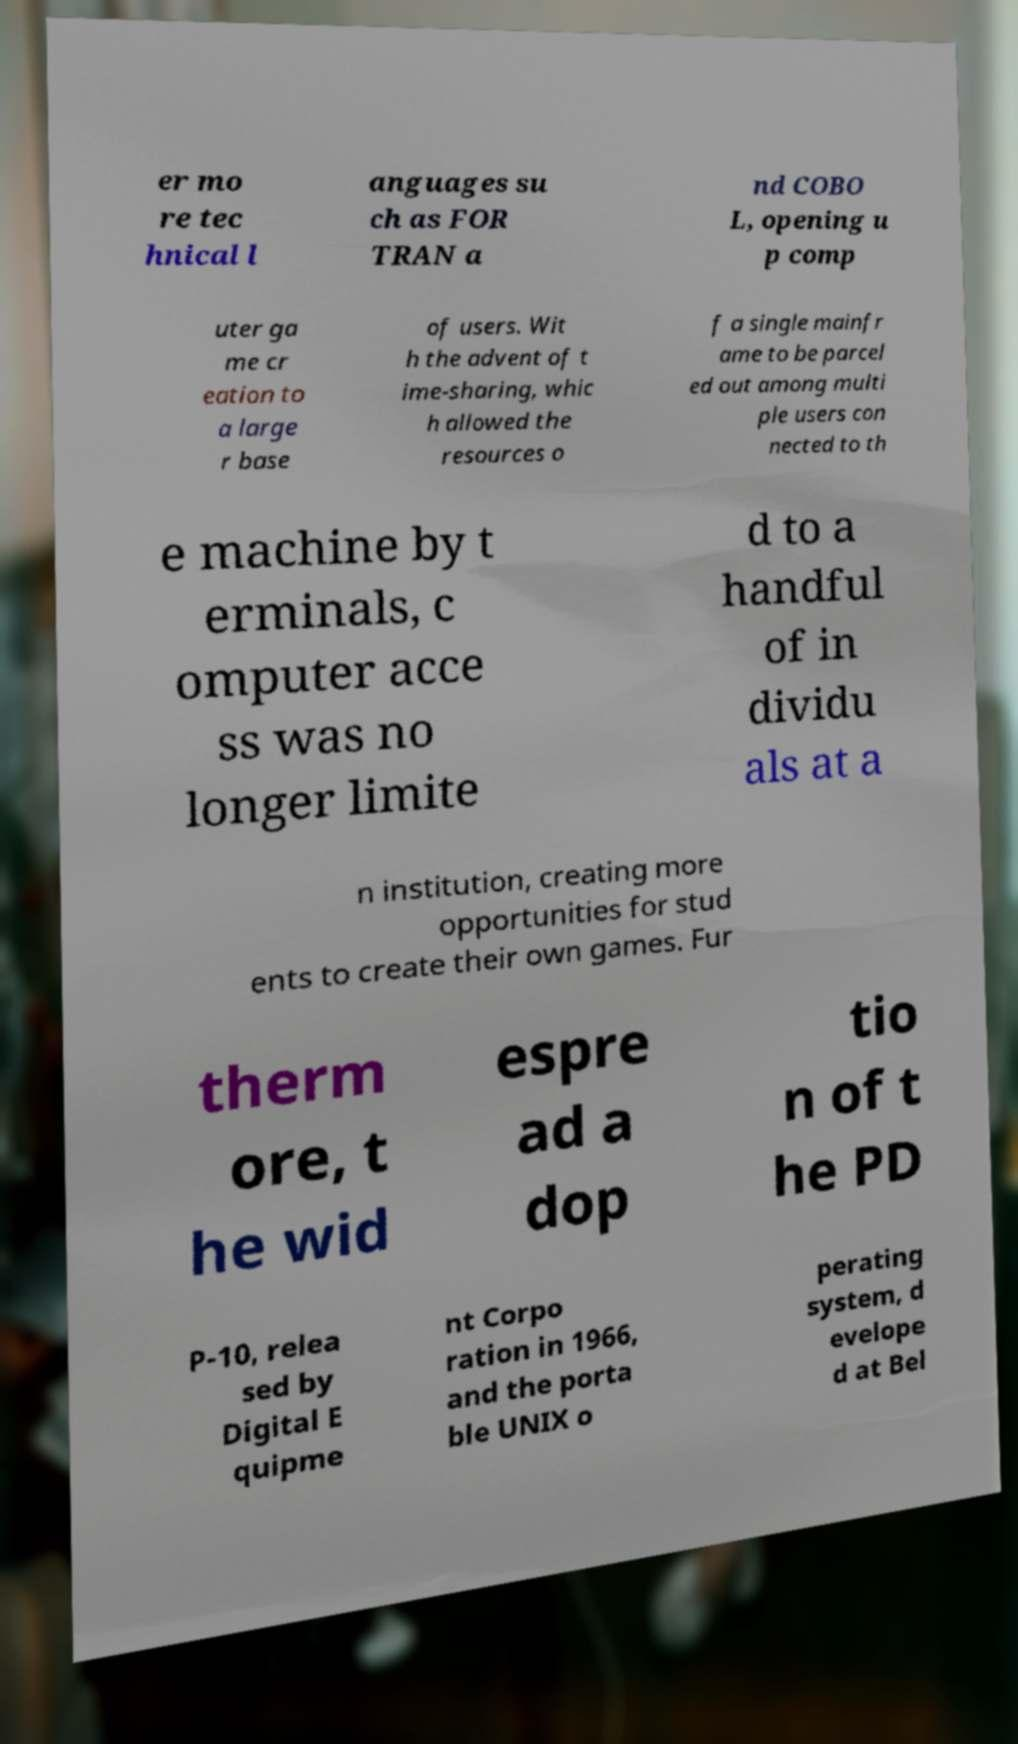I need the written content from this picture converted into text. Can you do that? er mo re tec hnical l anguages su ch as FOR TRAN a nd COBO L, opening u p comp uter ga me cr eation to a large r base of users. Wit h the advent of t ime-sharing, whic h allowed the resources o f a single mainfr ame to be parcel ed out among multi ple users con nected to th e machine by t erminals, c omputer acce ss was no longer limite d to a handful of in dividu als at a n institution, creating more opportunities for stud ents to create their own games. Fur therm ore, t he wid espre ad a dop tio n of t he PD P-10, relea sed by Digital E quipme nt Corpo ration in 1966, and the porta ble UNIX o perating system, d evelope d at Bel 